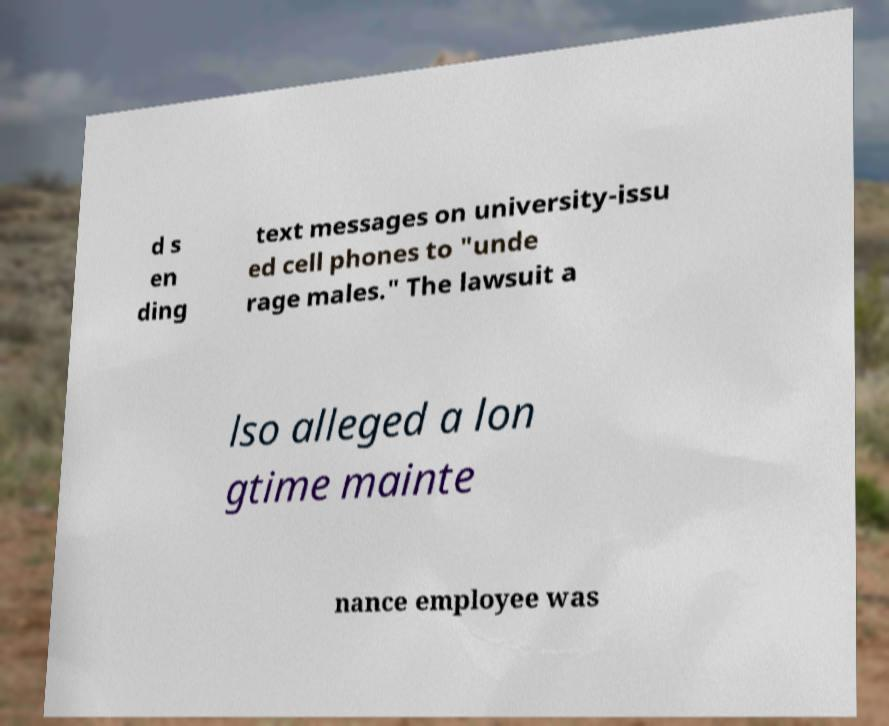Please identify and transcribe the text found in this image. d s en ding text messages on university-issu ed cell phones to "unde rage males." The lawsuit a lso alleged a lon gtime mainte nance employee was 